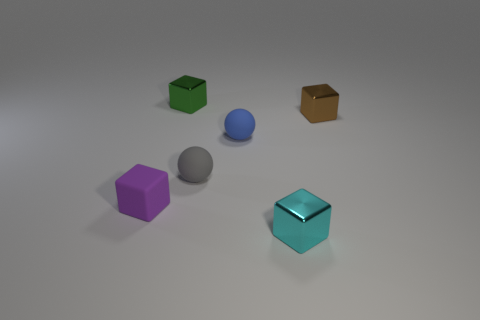Subtract 1 cubes. How many cubes are left? 3 Add 4 large balls. How many objects exist? 10 Subtract 0 blue cylinders. How many objects are left? 6 Subtract all spheres. How many objects are left? 4 Subtract all small green shiny things. Subtract all tiny purple cubes. How many objects are left? 4 Add 5 spheres. How many spheres are left? 7 Add 6 tiny green metallic cubes. How many tiny green metallic cubes exist? 7 